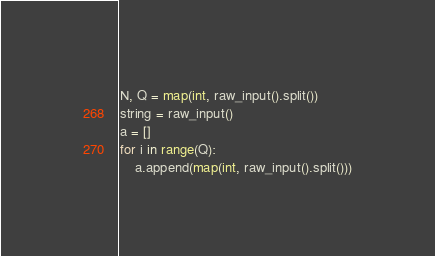<code> <loc_0><loc_0><loc_500><loc_500><_Python_>N, Q = map(int, raw_input().split())
string = raw_input()
a = []
for i in range(Q):
    a.append(map(int, raw_input().split()))</code> 